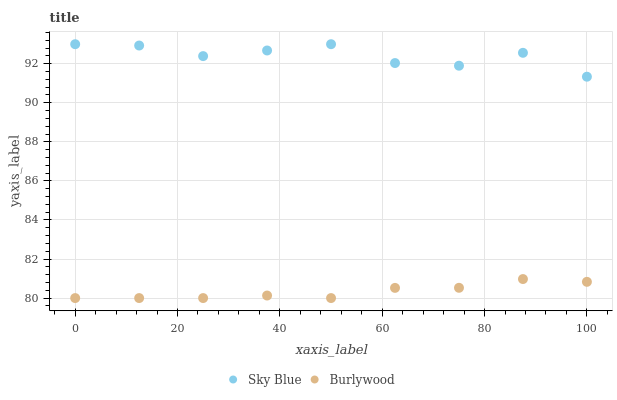Does Burlywood have the minimum area under the curve?
Answer yes or no. Yes. Does Sky Blue have the maximum area under the curve?
Answer yes or no. Yes. Does Sky Blue have the minimum area under the curve?
Answer yes or no. No. Is Burlywood the smoothest?
Answer yes or no. Yes. Is Sky Blue the roughest?
Answer yes or no. Yes. Is Sky Blue the smoothest?
Answer yes or no. No. Does Burlywood have the lowest value?
Answer yes or no. Yes. Does Sky Blue have the lowest value?
Answer yes or no. No. Does Sky Blue have the highest value?
Answer yes or no. Yes. Is Burlywood less than Sky Blue?
Answer yes or no. Yes. Is Sky Blue greater than Burlywood?
Answer yes or no. Yes. Does Burlywood intersect Sky Blue?
Answer yes or no. No. 